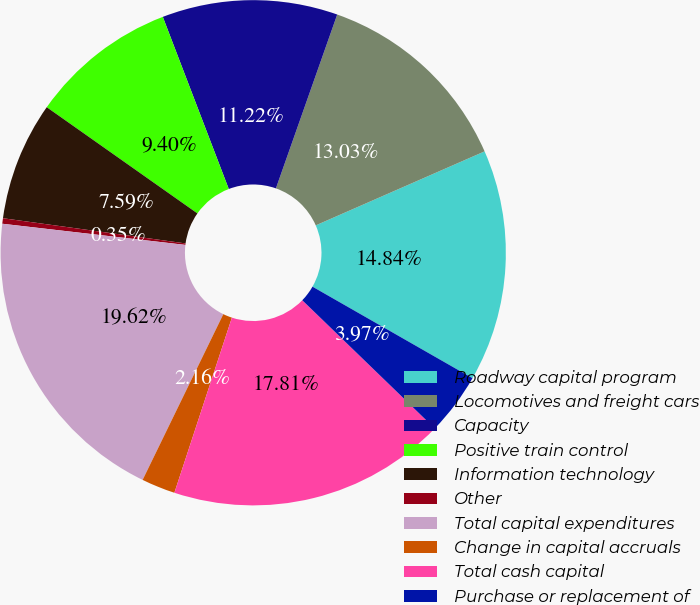Convert chart. <chart><loc_0><loc_0><loc_500><loc_500><pie_chart><fcel>Roadway capital program<fcel>Locomotives and freight cars<fcel>Capacity<fcel>Positive train control<fcel>Information technology<fcel>Other<fcel>Total capital expenditures<fcel>Change in capital accruals<fcel>Total cash capital<fcel>Purchase or replacement of<nl><fcel>14.84%<fcel>13.03%<fcel>11.22%<fcel>9.4%<fcel>7.59%<fcel>0.35%<fcel>19.62%<fcel>2.16%<fcel>17.81%<fcel>3.97%<nl></chart> 